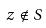Convert formula to latex. <formula><loc_0><loc_0><loc_500><loc_500>z \notin S</formula> 